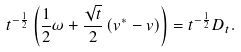<formula> <loc_0><loc_0><loc_500><loc_500>t ^ { - \frac { 1 } { 2 } } \left ( \frac { 1 } { 2 } \omega + \frac { \sqrt { t } } { 2 } \left ( v ^ { * } - v \right ) \right ) = t ^ { - \frac { 1 } { 2 } } D _ { t } .</formula> 